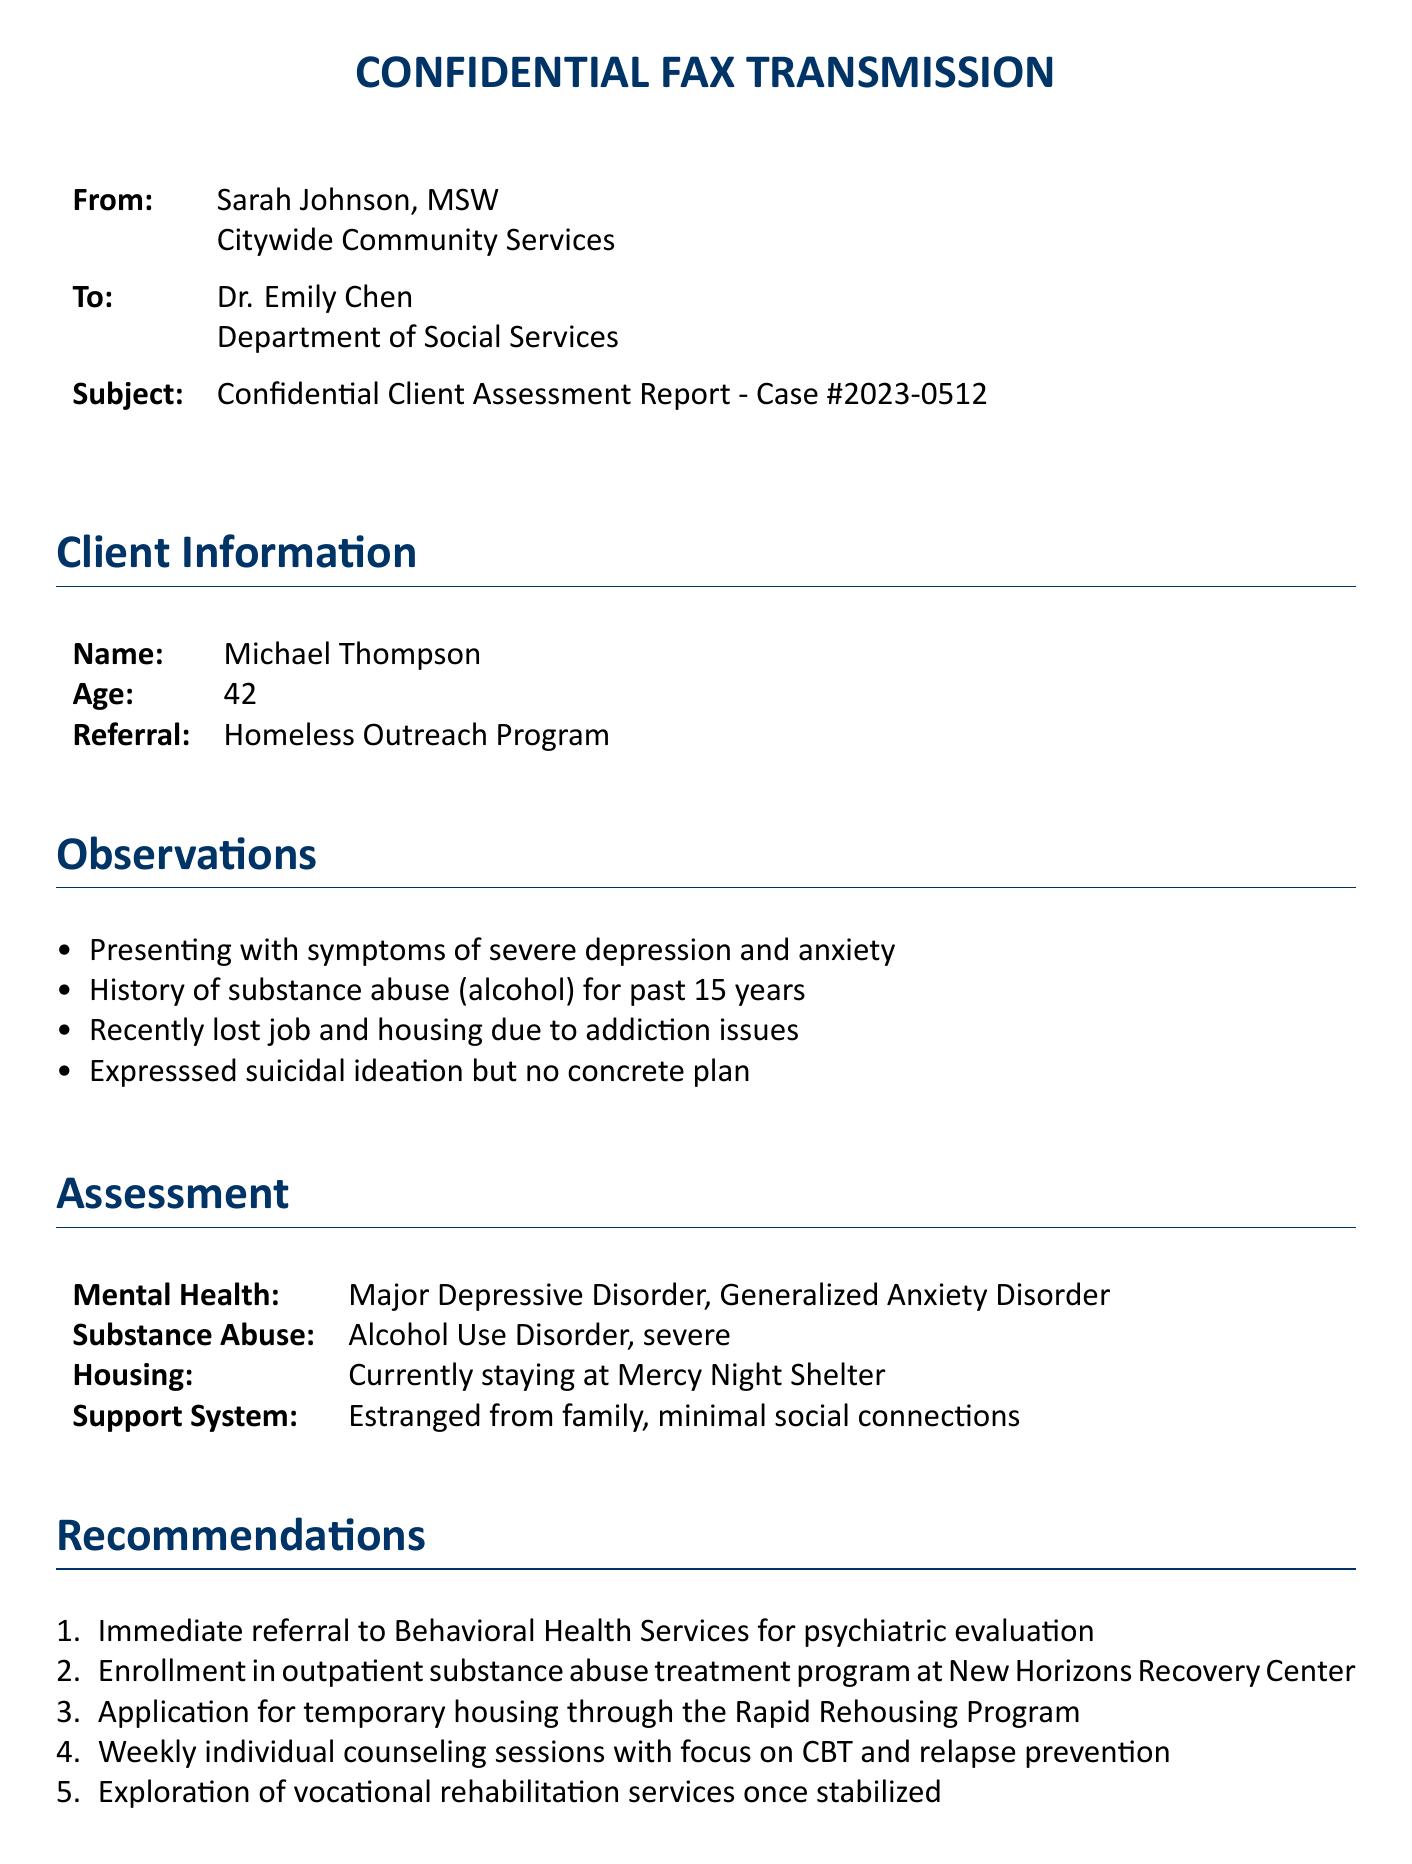What is the name of the client? The client's name is listed in the document under "Client Information."
Answer: Michael Thompson What is the age of the client? The age of the client is specified in the "Client Information" section.
Answer: 42 What referral program is mentioned in the document? The referral program is indicated in the "Client Information" section.
Answer: Homeless Outreach Program What is one of the symptoms observed in the client? The symptoms listed in the "Observations" section mention various issues.
Answer: Severe depression What is the suggested treatment program for substance abuse? The "Recommendations" section provides information on the treatment program.
Answer: Outpatient substance abuse treatment program at New Horizons Recovery Center When is the next appointment scheduled? The date for the next appointment is provided in the "Follow-up" section.
Answer: May 25, 2023 How is the client's support system described? The "Assessment" section outlines the client's social connections and family situation.
Answer: Estranged from family, minimal social connections What type of mental health disorder is diagnosed? The "Assessment" section specifies the mental health disorder.
Answer: Major Depressive Disorder What method is recommended for counseling? The "Recommendations" section suggests a specific counseling focus.
Answer: CBT and relapse prevention 